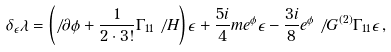<formula> <loc_0><loc_0><loc_500><loc_500>\delta _ { \epsilon } \lambda = \left ( \not \, \partial \phi + { \frac { 1 } { 2 \cdot 3 ! } } \Gamma _ { 1 1 } \not \, H \right ) \epsilon + { \frac { 5 i } { 4 } } m e ^ { \phi } \epsilon - { \frac { 3 i } { 8 } } e ^ { \phi } \not \, G ^ { ( 2 ) } \Gamma _ { 1 1 } \epsilon \, ,</formula> 